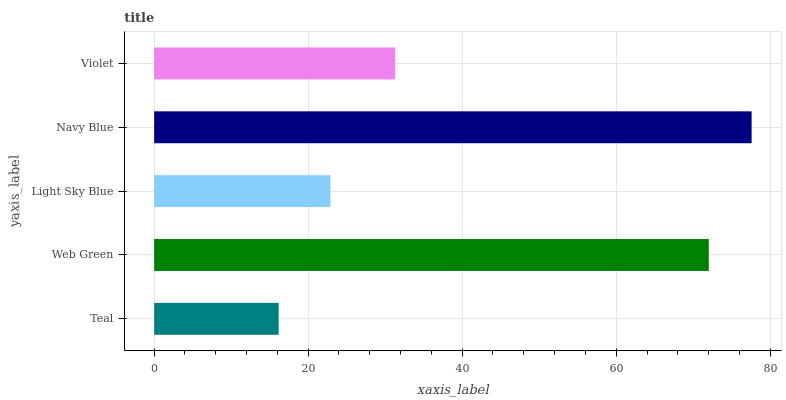Is Teal the minimum?
Answer yes or no. Yes. Is Navy Blue the maximum?
Answer yes or no. Yes. Is Web Green the minimum?
Answer yes or no. No. Is Web Green the maximum?
Answer yes or no. No. Is Web Green greater than Teal?
Answer yes or no. Yes. Is Teal less than Web Green?
Answer yes or no. Yes. Is Teal greater than Web Green?
Answer yes or no. No. Is Web Green less than Teal?
Answer yes or no. No. Is Violet the high median?
Answer yes or no. Yes. Is Violet the low median?
Answer yes or no. Yes. Is Navy Blue the high median?
Answer yes or no. No. Is Teal the low median?
Answer yes or no. No. 